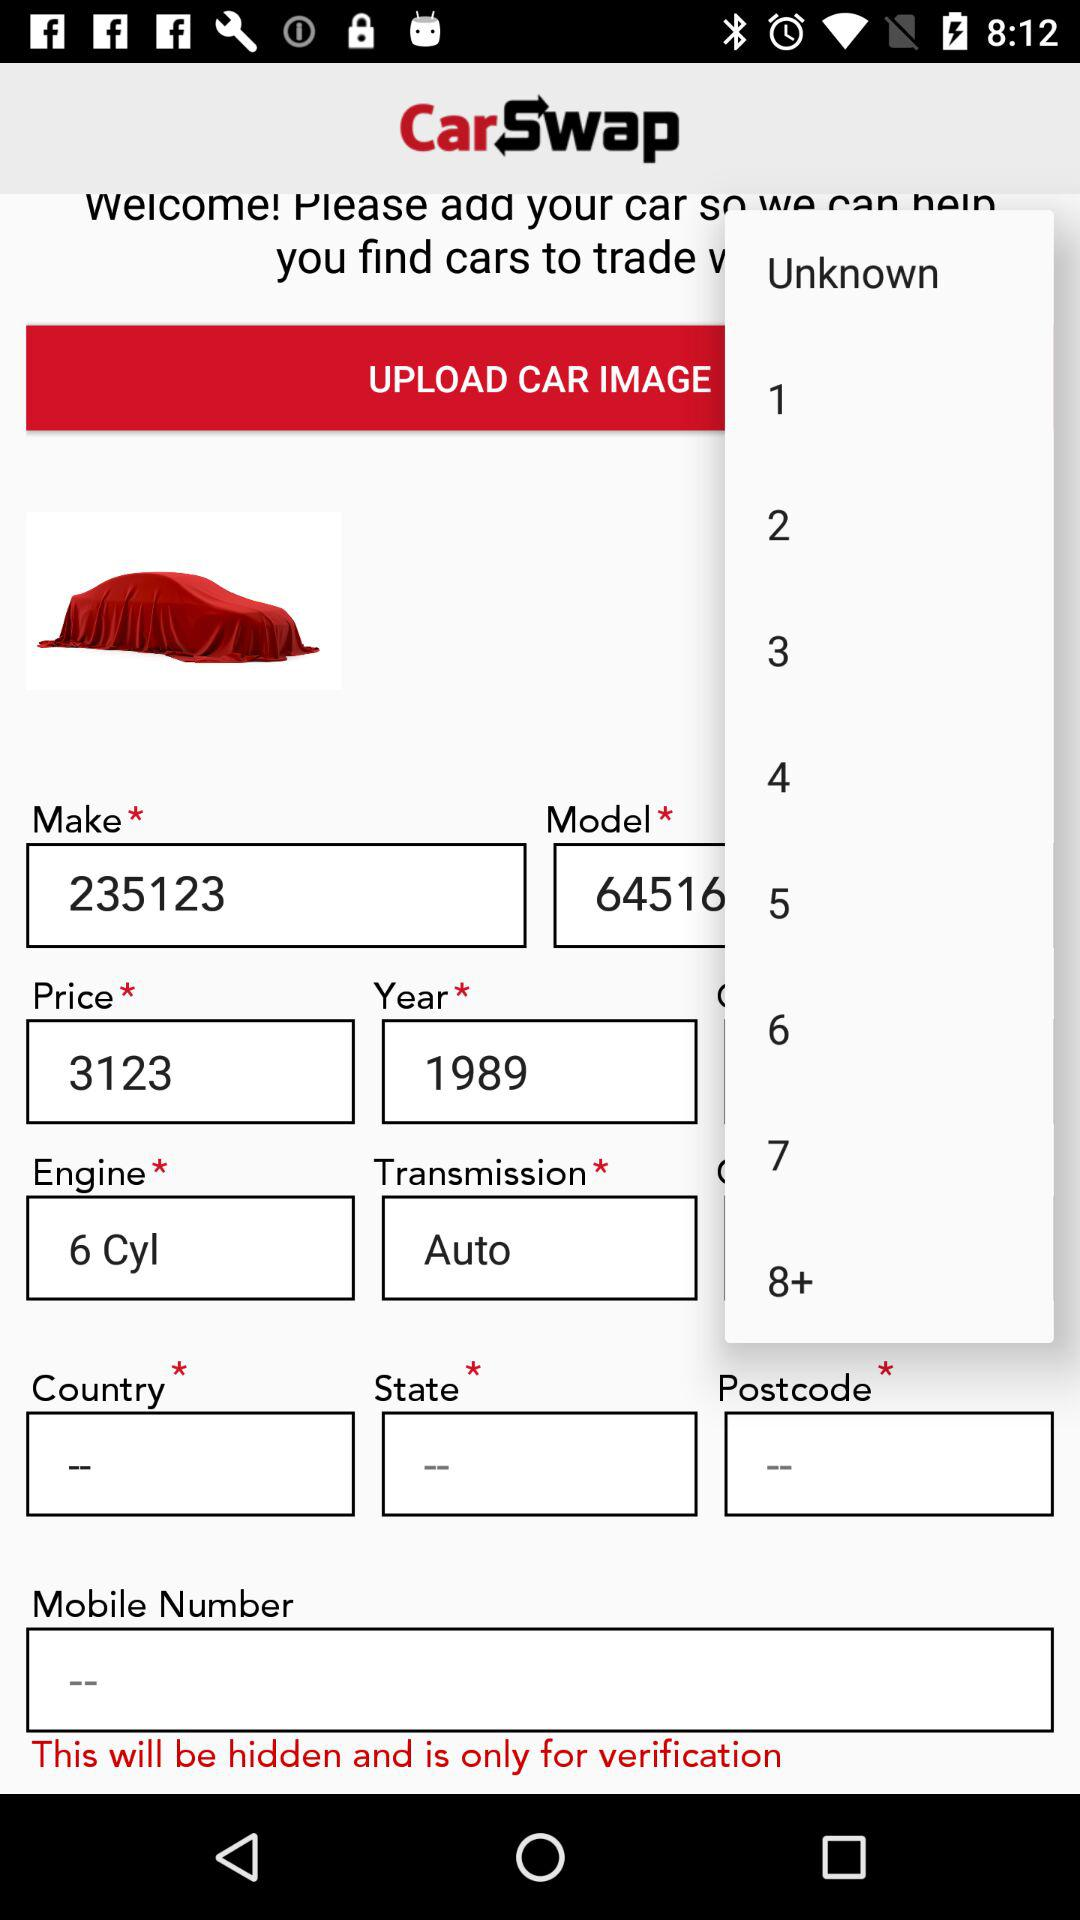What is the name of the application? The name of the application is "CarSwap". 